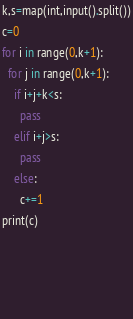Convert code to text. <code><loc_0><loc_0><loc_500><loc_500><_Python_>k,s=map(int,input().split())
c=0
for i in range(0,k+1):
  for j in range(0,k+1):
    if i+j+k<s:
      pass
    elif i+j>s:
      pass
    else:
      c+=1
print(c)
  

  
  </code> 